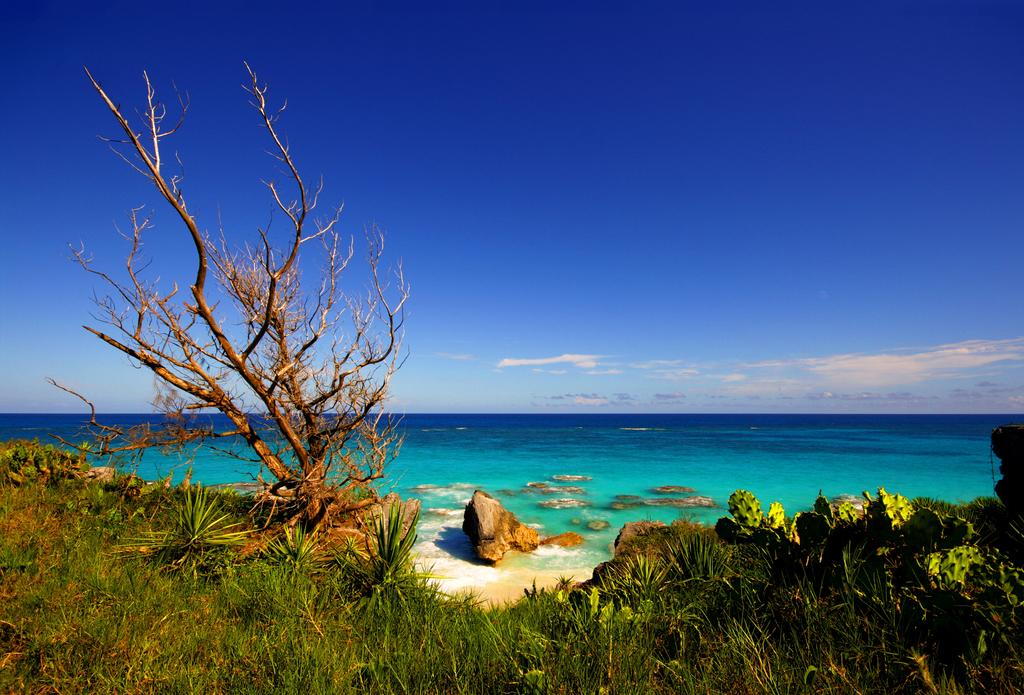What type of vegetation can be seen in the image? There is a tree, plants, and grass visible in the image. What can be seen in the background of the image? Water and the sky are visible in the background of the image. How many types of vegetation are present in the image? There are three types of vegetation present in the image: a tree, plants, and grass. Can you see a mountain in the image? There is no mountain present in the image. What type of tool is being used to transport the plants in the image? There is no tool or transport activity involving plants in the image. 